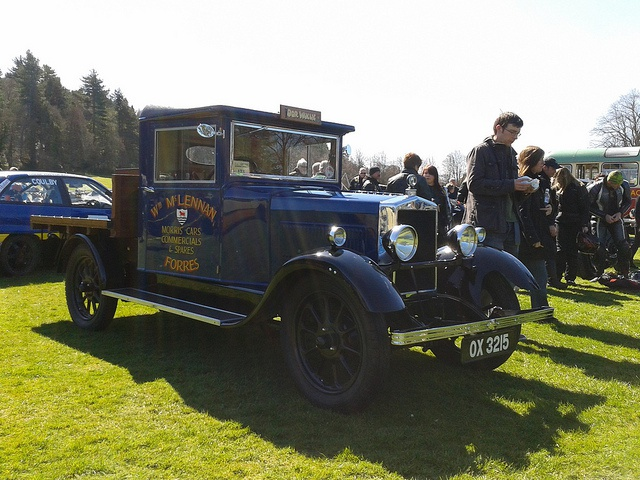Describe the objects in this image and their specific colors. I can see truck in white, black, gray, navy, and darkgreen tones, car in white, navy, black, gray, and darkblue tones, people in white, black, gray, darkgray, and lightgray tones, people in white, black, gray, and maroon tones, and people in white, black, gray, and darkgreen tones in this image. 